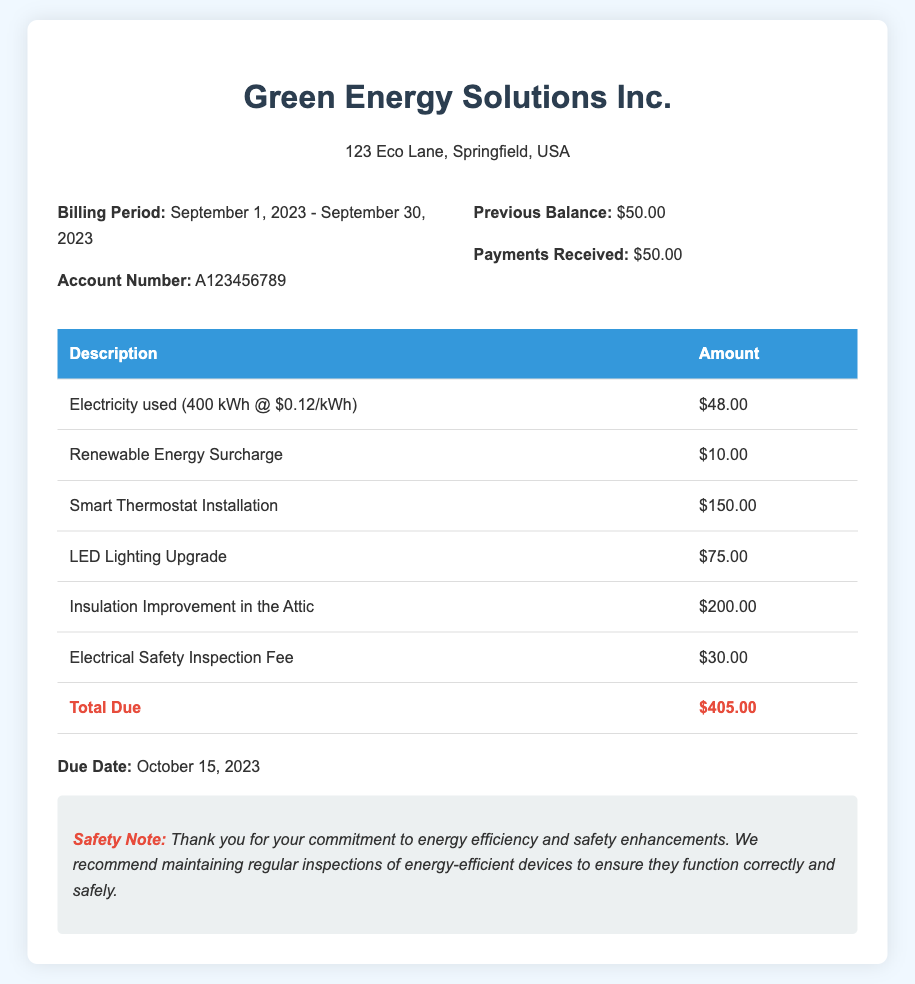What is the billing period? The billing period is specified as the duration for which the bill is calculated, from September 1, 2023, to September 30, 2023.
Answer: September 1, 2023 - September 30, 2023 What is the account number? The account number is a unique identifier for billing purposes, listed in the document for identification.
Answer: A123456789 What is the total due amount? The total due amount is the sum of all charges including usage and upgrades; it is specified at the end of the bill.
Answer: $405.00 What is one of the energy-efficient upgrades listed? The document includes various upgrades made for safety enhancements and energy efficiency, one of which is highlighted.
Answer: Smart Thermostat Installation What is the due date for the payment? The due date indicates when the payment needs to be made to avoid penalties, clearly mentioned in the bill.
Answer: October 15, 2023 How much is the Renewable Energy Surcharge? This item is specified in the list of charges and represents an additional fee related to renewable energy.
Answer: $10.00 What safety recommendation is mentioned? The document contains a note emphasizing the importance of safety checks and device maintenance for energy-efficient upgrades.
Answer: Regular inspections of energy-efficient devices What is the charge for the Electrical Safety Inspection Fee? This fee is part of the costs associated with ensuring safety standards are met and is itemized in the bill.
Answer: $30.00 How much was paid towards the previous balance? The document specifies the amount that was paid against the previous bills before listing the current charges.
Answer: $50.00 